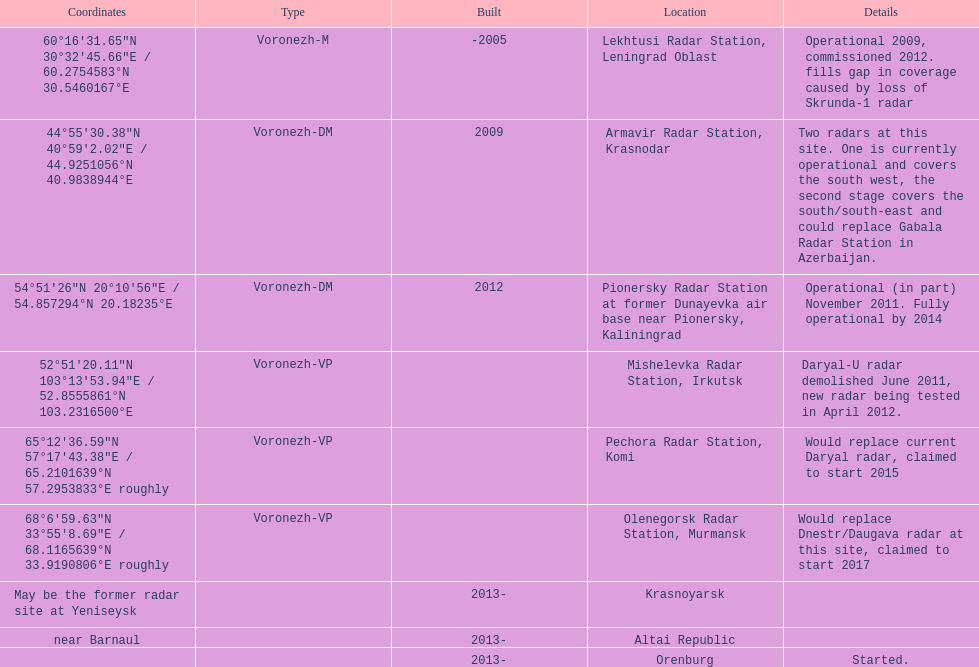What is the only location with a coordination of 60°16&#8242;31.65&#8243;n 30°32&#8242;45.66&#8243;e / 60.2754583°n 30.5460167°e? Lekhtusi Radar Station, Leningrad Oblast. 